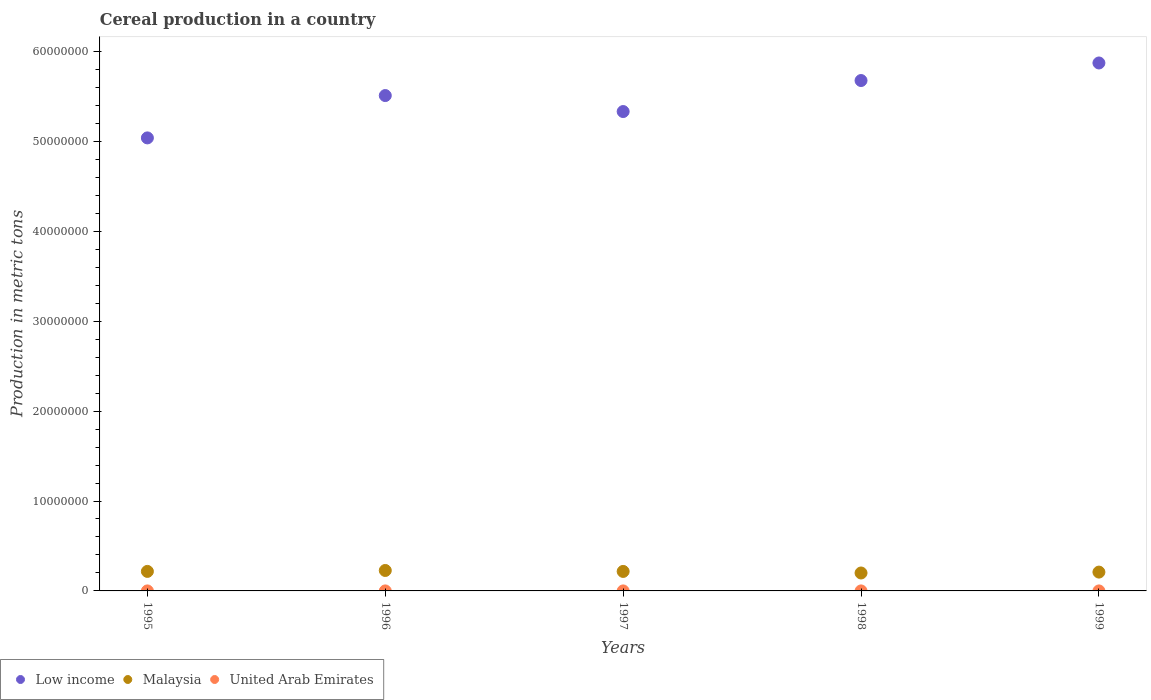What is the total cereal production in Malaysia in 1995?
Give a very brief answer. 2.17e+06. Across all years, what is the maximum total cereal production in Malaysia?
Your answer should be very brief. 2.27e+06. Across all years, what is the minimum total cereal production in Low income?
Give a very brief answer. 5.04e+07. What is the total total cereal production in United Arab Emirates in the graph?
Your answer should be compact. 2443. What is the difference between the total cereal production in Low income in 1995 and that in 1996?
Your answer should be very brief. -4.71e+06. What is the difference between the total cereal production in United Arab Emirates in 1998 and the total cereal production in Malaysia in 1997?
Provide a short and direct response. -2.17e+06. What is the average total cereal production in Malaysia per year?
Offer a very short reply. 2.14e+06. In the year 1997, what is the difference between the total cereal production in United Arab Emirates and total cereal production in Malaysia?
Give a very brief answer. -2.17e+06. What is the ratio of the total cereal production in Malaysia in 1995 to that in 1996?
Ensure brevity in your answer.  0.95. Is the total cereal production in United Arab Emirates in 1997 less than that in 1999?
Ensure brevity in your answer.  No. Is the difference between the total cereal production in United Arab Emirates in 1996 and 1998 greater than the difference between the total cereal production in Malaysia in 1996 and 1998?
Give a very brief answer. No. What is the difference between the highest and the second highest total cereal production in Low income?
Keep it short and to the point. 1.95e+06. What is the difference between the highest and the lowest total cereal production in United Arab Emirates?
Your response must be concise. 760. Is the total cereal production in Low income strictly greater than the total cereal production in United Arab Emirates over the years?
Your answer should be compact. Yes. How many dotlines are there?
Make the answer very short. 3. Does the graph contain any zero values?
Offer a very short reply. No. Where does the legend appear in the graph?
Your response must be concise. Bottom left. How many legend labels are there?
Make the answer very short. 3. What is the title of the graph?
Provide a succinct answer. Cereal production in a country. What is the label or title of the Y-axis?
Provide a short and direct response. Production in metric tons. What is the Production in metric tons in Low income in 1995?
Your answer should be compact. 5.04e+07. What is the Production in metric tons in Malaysia in 1995?
Give a very brief answer. 2.17e+06. What is the Production in metric tons of United Arab Emirates in 1995?
Your answer should be compact. 972. What is the Production in metric tons of Low income in 1996?
Give a very brief answer. 5.51e+07. What is the Production in metric tons of Malaysia in 1996?
Your response must be concise. 2.27e+06. What is the Production in metric tons of United Arab Emirates in 1996?
Make the answer very short. 601. What is the Production in metric tons in Low income in 1997?
Provide a succinct answer. 5.33e+07. What is the Production in metric tons in Malaysia in 1997?
Your response must be concise. 2.17e+06. What is the Production in metric tons in United Arab Emirates in 1997?
Your response must be concise. 298. What is the Production in metric tons of Low income in 1998?
Keep it short and to the point. 5.68e+07. What is the Production in metric tons of Malaysia in 1998?
Provide a succinct answer. 1.99e+06. What is the Production in metric tons of United Arab Emirates in 1998?
Make the answer very short. 360. What is the Production in metric tons in Low income in 1999?
Offer a very short reply. 5.87e+07. What is the Production in metric tons of Malaysia in 1999?
Offer a very short reply. 2.09e+06. What is the Production in metric tons of United Arab Emirates in 1999?
Provide a short and direct response. 212. Across all years, what is the maximum Production in metric tons in Low income?
Provide a short and direct response. 5.87e+07. Across all years, what is the maximum Production in metric tons of Malaysia?
Your answer should be very brief. 2.27e+06. Across all years, what is the maximum Production in metric tons in United Arab Emirates?
Give a very brief answer. 972. Across all years, what is the minimum Production in metric tons of Low income?
Your answer should be very brief. 5.04e+07. Across all years, what is the minimum Production in metric tons in Malaysia?
Your response must be concise. 1.99e+06. Across all years, what is the minimum Production in metric tons in United Arab Emirates?
Your response must be concise. 212. What is the total Production in metric tons of Low income in the graph?
Provide a short and direct response. 2.74e+08. What is the total Production in metric tons of Malaysia in the graph?
Your answer should be very brief. 1.07e+07. What is the total Production in metric tons in United Arab Emirates in the graph?
Ensure brevity in your answer.  2443. What is the difference between the Production in metric tons in Low income in 1995 and that in 1996?
Provide a succinct answer. -4.71e+06. What is the difference between the Production in metric tons in Malaysia in 1995 and that in 1996?
Your answer should be very brief. -1.03e+05. What is the difference between the Production in metric tons of United Arab Emirates in 1995 and that in 1996?
Ensure brevity in your answer.  371. What is the difference between the Production in metric tons of Low income in 1995 and that in 1997?
Offer a very short reply. -2.93e+06. What is the difference between the Production in metric tons of Malaysia in 1995 and that in 1997?
Provide a short and direct response. 2656. What is the difference between the Production in metric tons of United Arab Emirates in 1995 and that in 1997?
Offer a very short reply. 674. What is the difference between the Production in metric tons of Low income in 1995 and that in 1998?
Keep it short and to the point. -6.38e+06. What is the difference between the Production in metric tons in Malaysia in 1995 and that in 1998?
Give a very brief answer. 1.76e+05. What is the difference between the Production in metric tons in United Arab Emirates in 1995 and that in 1998?
Your answer should be very brief. 612. What is the difference between the Production in metric tons in Low income in 1995 and that in 1999?
Your response must be concise. -8.33e+06. What is the difference between the Production in metric tons of Malaysia in 1995 and that in 1999?
Offer a terse response. 7.66e+04. What is the difference between the Production in metric tons of United Arab Emirates in 1995 and that in 1999?
Offer a very short reply. 760. What is the difference between the Production in metric tons in Low income in 1996 and that in 1997?
Provide a succinct answer. 1.78e+06. What is the difference between the Production in metric tons in Malaysia in 1996 and that in 1997?
Provide a short and direct response. 1.06e+05. What is the difference between the Production in metric tons in United Arab Emirates in 1996 and that in 1997?
Provide a short and direct response. 303. What is the difference between the Production in metric tons of Low income in 1996 and that in 1998?
Make the answer very short. -1.67e+06. What is the difference between the Production in metric tons in Malaysia in 1996 and that in 1998?
Offer a terse response. 2.79e+05. What is the difference between the Production in metric tons in United Arab Emirates in 1996 and that in 1998?
Keep it short and to the point. 241. What is the difference between the Production in metric tons in Low income in 1996 and that in 1999?
Your answer should be very brief. -3.62e+06. What is the difference between the Production in metric tons of Malaysia in 1996 and that in 1999?
Give a very brief answer. 1.80e+05. What is the difference between the Production in metric tons in United Arab Emirates in 1996 and that in 1999?
Keep it short and to the point. 389. What is the difference between the Production in metric tons in Low income in 1997 and that in 1998?
Make the answer very short. -3.45e+06. What is the difference between the Production in metric tons of Malaysia in 1997 and that in 1998?
Provide a short and direct response. 1.73e+05. What is the difference between the Production in metric tons in United Arab Emirates in 1997 and that in 1998?
Your response must be concise. -62. What is the difference between the Production in metric tons of Low income in 1997 and that in 1999?
Provide a succinct answer. -5.40e+06. What is the difference between the Production in metric tons in Malaysia in 1997 and that in 1999?
Provide a succinct answer. 7.40e+04. What is the difference between the Production in metric tons in United Arab Emirates in 1997 and that in 1999?
Offer a terse response. 86. What is the difference between the Production in metric tons in Low income in 1998 and that in 1999?
Your answer should be very brief. -1.95e+06. What is the difference between the Production in metric tons of Malaysia in 1998 and that in 1999?
Ensure brevity in your answer.  -9.94e+04. What is the difference between the Production in metric tons in United Arab Emirates in 1998 and that in 1999?
Keep it short and to the point. 148. What is the difference between the Production in metric tons of Low income in 1995 and the Production in metric tons of Malaysia in 1996?
Your answer should be very brief. 4.81e+07. What is the difference between the Production in metric tons of Low income in 1995 and the Production in metric tons of United Arab Emirates in 1996?
Offer a terse response. 5.04e+07. What is the difference between the Production in metric tons in Malaysia in 1995 and the Production in metric tons in United Arab Emirates in 1996?
Provide a short and direct response. 2.17e+06. What is the difference between the Production in metric tons of Low income in 1995 and the Production in metric tons of Malaysia in 1997?
Ensure brevity in your answer.  4.82e+07. What is the difference between the Production in metric tons of Low income in 1995 and the Production in metric tons of United Arab Emirates in 1997?
Provide a succinct answer. 5.04e+07. What is the difference between the Production in metric tons in Malaysia in 1995 and the Production in metric tons in United Arab Emirates in 1997?
Give a very brief answer. 2.17e+06. What is the difference between the Production in metric tons in Low income in 1995 and the Production in metric tons in Malaysia in 1998?
Offer a very short reply. 4.84e+07. What is the difference between the Production in metric tons in Low income in 1995 and the Production in metric tons in United Arab Emirates in 1998?
Give a very brief answer. 5.04e+07. What is the difference between the Production in metric tons of Malaysia in 1995 and the Production in metric tons of United Arab Emirates in 1998?
Your answer should be very brief. 2.17e+06. What is the difference between the Production in metric tons of Low income in 1995 and the Production in metric tons of Malaysia in 1999?
Your response must be concise. 4.83e+07. What is the difference between the Production in metric tons in Low income in 1995 and the Production in metric tons in United Arab Emirates in 1999?
Ensure brevity in your answer.  5.04e+07. What is the difference between the Production in metric tons of Malaysia in 1995 and the Production in metric tons of United Arab Emirates in 1999?
Offer a terse response. 2.17e+06. What is the difference between the Production in metric tons in Low income in 1996 and the Production in metric tons in Malaysia in 1997?
Make the answer very short. 5.29e+07. What is the difference between the Production in metric tons in Low income in 1996 and the Production in metric tons in United Arab Emirates in 1997?
Ensure brevity in your answer.  5.51e+07. What is the difference between the Production in metric tons of Malaysia in 1996 and the Production in metric tons of United Arab Emirates in 1997?
Provide a short and direct response. 2.27e+06. What is the difference between the Production in metric tons in Low income in 1996 and the Production in metric tons in Malaysia in 1998?
Give a very brief answer. 5.31e+07. What is the difference between the Production in metric tons in Low income in 1996 and the Production in metric tons in United Arab Emirates in 1998?
Your answer should be very brief. 5.51e+07. What is the difference between the Production in metric tons of Malaysia in 1996 and the Production in metric tons of United Arab Emirates in 1998?
Your response must be concise. 2.27e+06. What is the difference between the Production in metric tons in Low income in 1996 and the Production in metric tons in Malaysia in 1999?
Your response must be concise. 5.30e+07. What is the difference between the Production in metric tons of Low income in 1996 and the Production in metric tons of United Arab Emirates in 1999?
Make the answer very short. 5.51e+07. What is the difference between the Production in metric tons of Malaysia in 1996 and the Production in metric tons of United Arab Emirates in 1999?
Offer a terse response. 2.27e+06. What is the difference between the Production in metric tons of Low income in 1997 and the Production in metric tons of Malaysia in 1998?
Keep it short and to the point. 5.13e+07. What is the difference between the Production in metric tons of Low income in 1997 and the Production in metric tons of United Arab Emirates in 1998?
Your answer should be compact. 5.33e+07. What is the difference between the Production in metric tons of Malaysia in 1997 and the Production in metric tons of United Arab Emirates in 1998?
Offer a very short reply. 2.17e+06. What is the difference between the Production in metric tons of Low income in 1997 and the Production in metric tons of Malaysia in 1999?
Provide a short and direct response. 5.12e+07. What is the difference between the Production in metric tons of Low income in 1997 and the Production in metric tons of United Arab Emirates in 1999?
Your response must be concise. 5.33e+07. What is the difference between the Production in metric tons of Malaysia in 1997 and the Production in metric tons of United Arab Emirates in 1999?
Provide a succinct answer. 2.17e+06. What is the difference between the Production in metric tons in Low income in 1998 and the Production in metric tons in Malaysia in 1999?
Your answer should be very brief. 5.47e+07. What is the difference between the Production in metric tons in Low income in 1998 and the Production in metric tons in United Arab Emirates in 1999?
Provide a succinct answer. 5.68e+07. What is the difference between the Production in metric tons in Malaysia in 1998 and the Production in metric tons in United Arab Emirates in 1999?
Give a very brief answer. 1.99e+06. What is the average Production in metric tons in Low income per year?
Keep it short and to the point. 5.49e+07. What is the average Production in metric tons in Malaysia per year?
Ensure brevity in your answer.  2.14e+06. What is the average Production in metric tons of United Arab Emirates per year?
Make the answer very short. 488.6. In the year 1995, what is the difference between the Production in metric tons of Low income and Production in metric tons of Malaysia?
Give a very brief answer. 4.82e+07. In the year 1995, what is the difference between the Production in metric tons in Low income and Production in metric tons in United Arab Emirates?
Make the answer very short. 5.04e+07. In the year 1995, what is the difference between the Production in metric tons in Malaysia and Production in metric tons in United Arab Emirates?
Provide a short and direct response. 2.17e+06. In the year 1996, what is the difference between the Production in metric tons of Low income and Production in metric tons of Malaysia?
Your answer should be compact. 5.28e+07. In the year 1996, what is the difference between the Production in metric tons of Low income and Production in metric tons of United Arab Emirates?
Make the answer very short. 5.51e+07. In the year 1996, what is the difference between the Production in metric tons of Malaysia and Production in metric tons of United Arab Emirates?
Offer a terse response. 2.27e+06. In the year 1997, what is the difference between the Production in metric tons of Low income and Production in metric tons of Malaysia?
Offer a very short reply. 5.11e+07. In the year 1997, what is the difference between the Production in metric tons in Low income and Production in metric tons in United Arab Emirates?
Offer a terse response. 5.33e+07. In the year 1997, what is the difference between the Production in metric tons of Malaysia and Production in metric tons of United Arab Emirates?
Your answer should be compact. 2.17e+06. In the year 1998, what is the difference between the Production in metric tons in Low income and Production in metric tons in Malaysia?
Your answer should be compact. 5.48e+07. In the year 1998, what is the difference between the Production in metric tons of Low income and Production in metric tons of United Arab Emirates?
Ensure brevity in your answer.  5.68e+07. In the year 1998, what is the difference between the Production in metric tons of Malaysia and Production in metric tons of United Arab Emirates?
Provide a succinct answer. 1.99e+06. In the year 1999, what is the difference between the Production in metric tons of Low income and Production in metric tons of Malaysia?
Provide a succinct answer. 5.66e+07. In the year 1999, what is the difference between the Production in metric tons of Low income and Production in metric tons of United Arab Emirates?
Your answer should be very brief. 5.87e+07. In the year 1999, what is the difference between the Production in metric tons in Malaysia and Production in metric tons in United Arab Emirates?
Your answer should be very brief. 2.09e+06. What is the ratio of the Production in metric tons in Low income in 1995 to that in 1996?
Your answer should be very brief. 0.91. What is the ratio of the Production in metric tons of Malaysia in 1995 to that in 1996?
Offer a very short reply. 0.95. What is the ratio of the Production in metric tons of United Arab Emirates in 1995 to that in 1996?
Ensure brevity in your answer.  1.62. What is the ratio of the Production in metric tons of Low income in 1995 to that in 1997?
Offer a terse response. 0.94. What is the ratio of the Production in metric tons in Malaysia in 1995 to that in 1997?
Ensure brevity in your answer.  1. What is the ratio of the Production in metric tons of United Arab Emirates in 1995 to that in 1997?
Your response must be concise. 3.26. What is the ratio of the Production in metric tons of Low income in 1995 to that in 1998?
Offer a very short reply. 0.89. What is the ratio of the Production in metric tons in Malaysia in 1995 to that in 1998?
Offer a terse response. 1.09. What is the ratio of the Production in metric tons of United Arab Emirates in 1995 to that in 1998?
Your answer should be very brief. 2.7. What is the ratio of the Production in metric tons of Low income in 1995 to that in 1999?
Provide a short and direct response. 0.86. What is the ratio of the Production in metric tons of Malaysia in 1995 to that in 1999?
Ensure brevity in your answer.  1.04. What is the ratio of the Production in metric tons in United Arab Emirates in 1995 to that in 1999?
Your answer should be compact. 4.58. What is the ratio of the Production in metric tons of Malaysia in 1996 to that in 1997?
Offer a terse response. 1.05. What is the ratio of the Production in metric tons of United Arab Emirates in 1996 to that in 1997?
Your answer should be very brief. 2.02. What is the ratio of the Production in metric tons in Low income in 1996 to that in 1998?
Your response must be concise. 0.97. What is the ratio of the Production in metric tons in Malaysia in 1996 to that in 1998?
Offer a very short reply. 1.14. What is the ratio of the Production in metric tons of United Arab Emirates in 1996 to that in 1998?
Make the answer very short. 1.67. What is the ratio of the Production in metric tons in Low income in 1996 to that in 1999?
Your answer should be compact. 0.94. What is the ratio of the Production in metric tons of Malaysia in 1996 to that in 1999?
Your response must be concise. 1.09. What is the ratio of the Production in metric tons in United Arab Emirates in 1996 to that in 1999?
Keep it short and to the point. 2.83. What is the ratio of the Production in metric tons of Low income in 1997 to that in 1998?
Offer a terse response. 0.94. What is the ratio of the Production in metric tons in Malaysia in 1997 to that in 1998?
Ensure brevity in your answer.  1.09. What is the ratio of the Production in metric tons of United Arab Emirates in 1997 to that in 1998?
Your response must be concise. 0.83. What is the ratio of the Production in metric tons in Low income in 1997 to that in 1999?
Provide a succinct answer. 0.91. What is the ratio of the Production in metric tons of Malaysia in 1997 to that in 1999?
Keep it short and to the point. 1.04. What is the ratio of the Production in metric tons in United Arab Emirates in 1997 to that in 1999?
Your answer should be compact. 1.41. What is the ratio of the Production in metric tons in Low income in 1998 to that in 1999?
Keep it short and to the point. 0.97. What is the ratio of the Production in metric tons of Malaysia in 1998 to that in 1999?
Make the answer very short. 0.95. What is the ratio of the Production in metric tons of United Arab Emirates in 1998 to that in 1999?
Offer a terse response. 1.7. What is the difference between the highest and the second highest Production in metric tons of Low income?
Your answer should be compact. 1.95e+06. What is the difference between the highest and the second highest Production in metric tons of Malaysia?
Give a very brief answer. 1.03e+05. What is the difference between the highest and the second highest Production in metric tons in United Arab Emirates?
Give a very brief answer. 371. What is the difference between the highest and the lowest Production in metric tons in Low income?
Your answer should be very brief. 8.33e+06. What is the difference between the highest and the lowest Production in metric tons in Malaysia?
Ensure brevity in your answer.  2.79e+05. What is the difference between the highest and the lowest Production in metric tons of United Arab Emirates?
Your answer should be very brief. 760. 